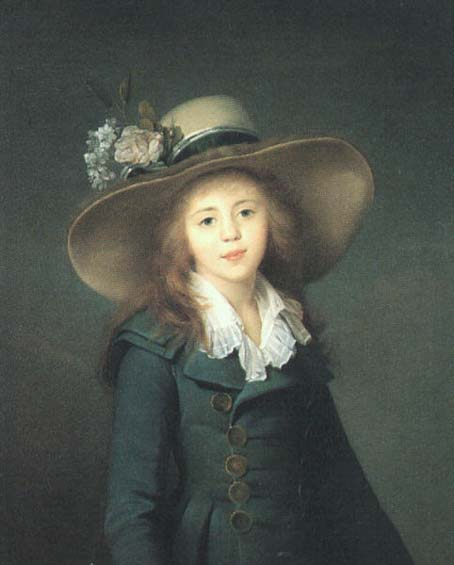What do you see happening in this image? The image features a young girl wearing a large, elaborately decorated hat adorned with flowers and a blue jacket punctuated with golden buttons. Her white ruffled collar adds a touch of elegance, beautifully contrasting with the deep blue of her jacket. The realistic art style focuses primarily on the girl, accentuating her gentle expression and the softness of her features, which are highlighted against a muted, dark gray backdrop. The composition and attire suggest a formal portrait, possibly intended to emphasize youth and elegance in a stylized, classical manner. 